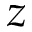Convert formula to latex. <formula><loc_0><loc_0><loc_500><loc_500>z</formula> 